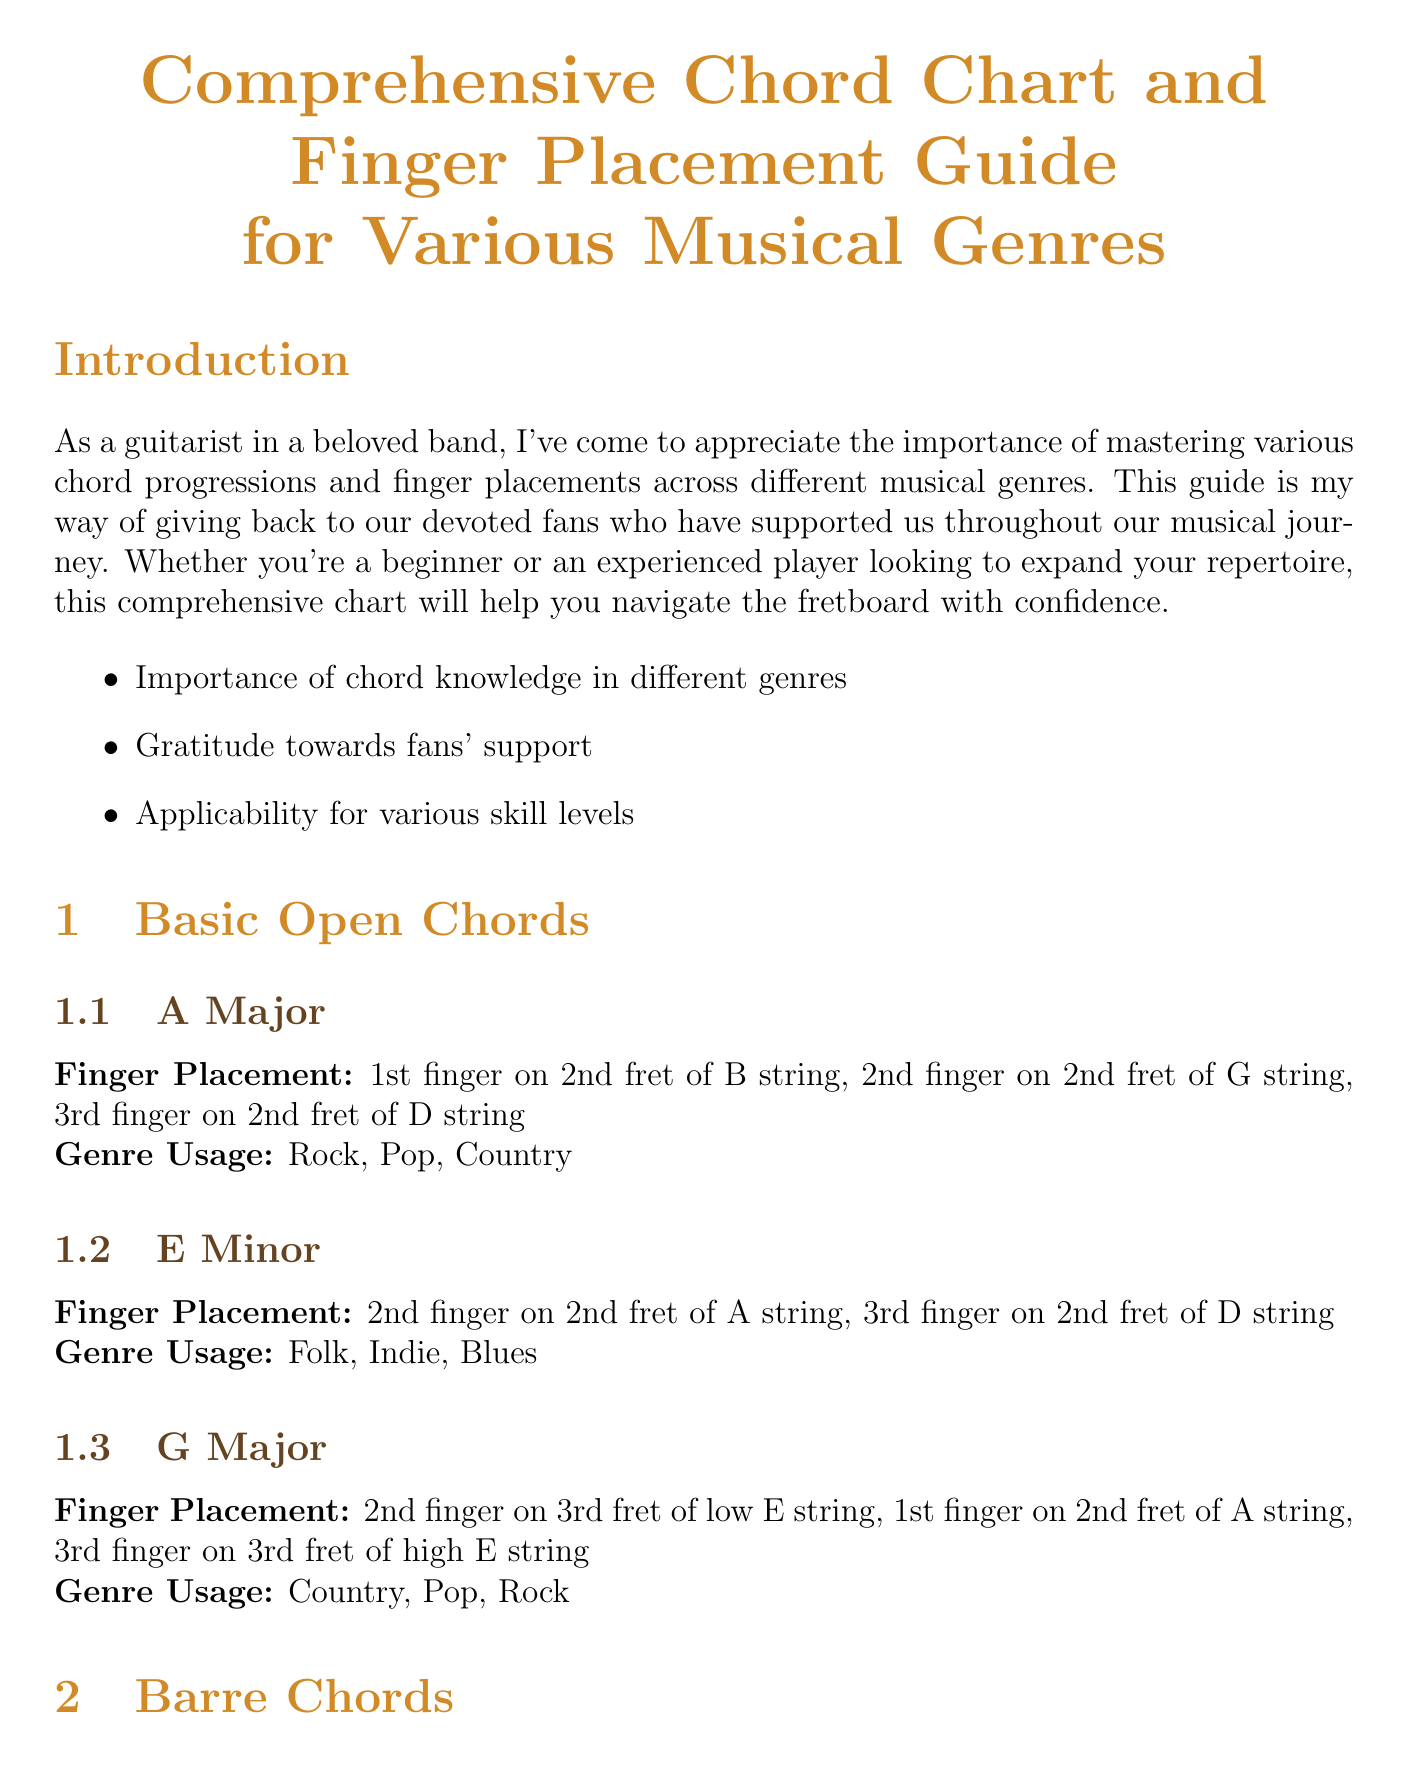what is the title of the document? The title is the main heading of the document, which summarizes its content.
Answer: Comprehensive Chord Chart and Finger Placement Guide for Various Musical Genres who is the author of the guide? The author is indicated within the introduction of the document, reflecting their position.
Answer: a guitarist in a beloved band how many sections does the document have? The number of sections is counted within the document to understand its structure.
Answer: Five which chord uses a barre on the 2nd fret? This refers to a specific chord example that utilizes barre technique as described in the document.
Answer: B Minor what genre commonly uses E Minor? This is found in the genre usage associated with the E Minor chord, highlighting its application.
Answer: Folk, Indie, Blues List one practice tip provided in the guide. Practice tips are included towards the end and help in improving skills.
Answer: Start slow and focus on clean transitions between chords what is the genre usage for A5? The genre usage specifies the musical genres where the chord A5 is most commonly applied.
Answer: Punk, Grunge, Hard Rock what is one of the key takeaways from the conclusion? Key takeaways are highlighted at the end, summarizing important points from the document.
Answer: Continuous practice and experimentation 